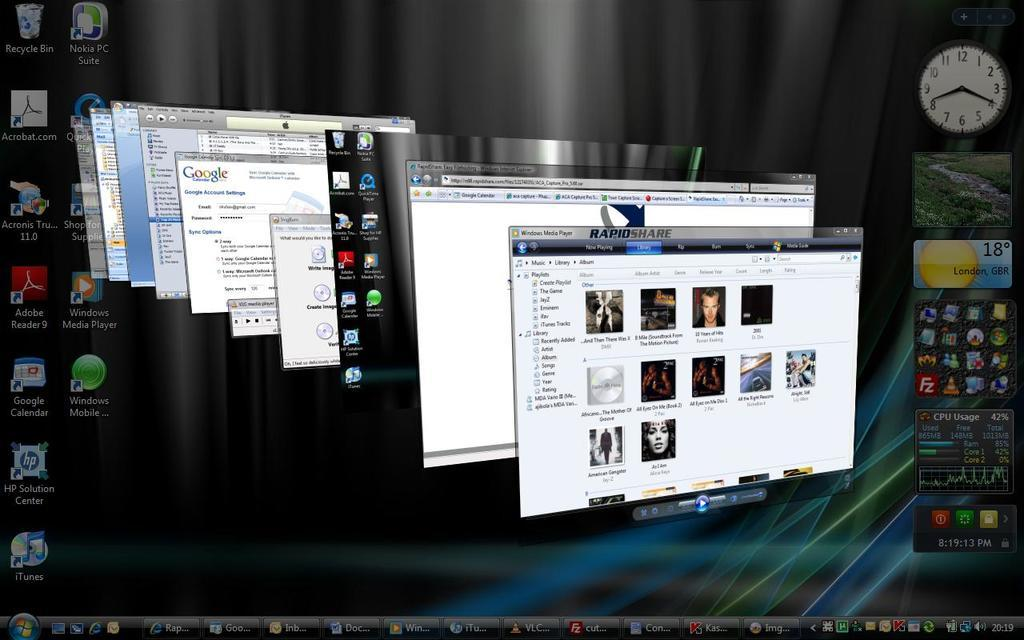<image>
Render a clear and concise summary of the photo. Many screens with oine that says "RapidShare" on it. 